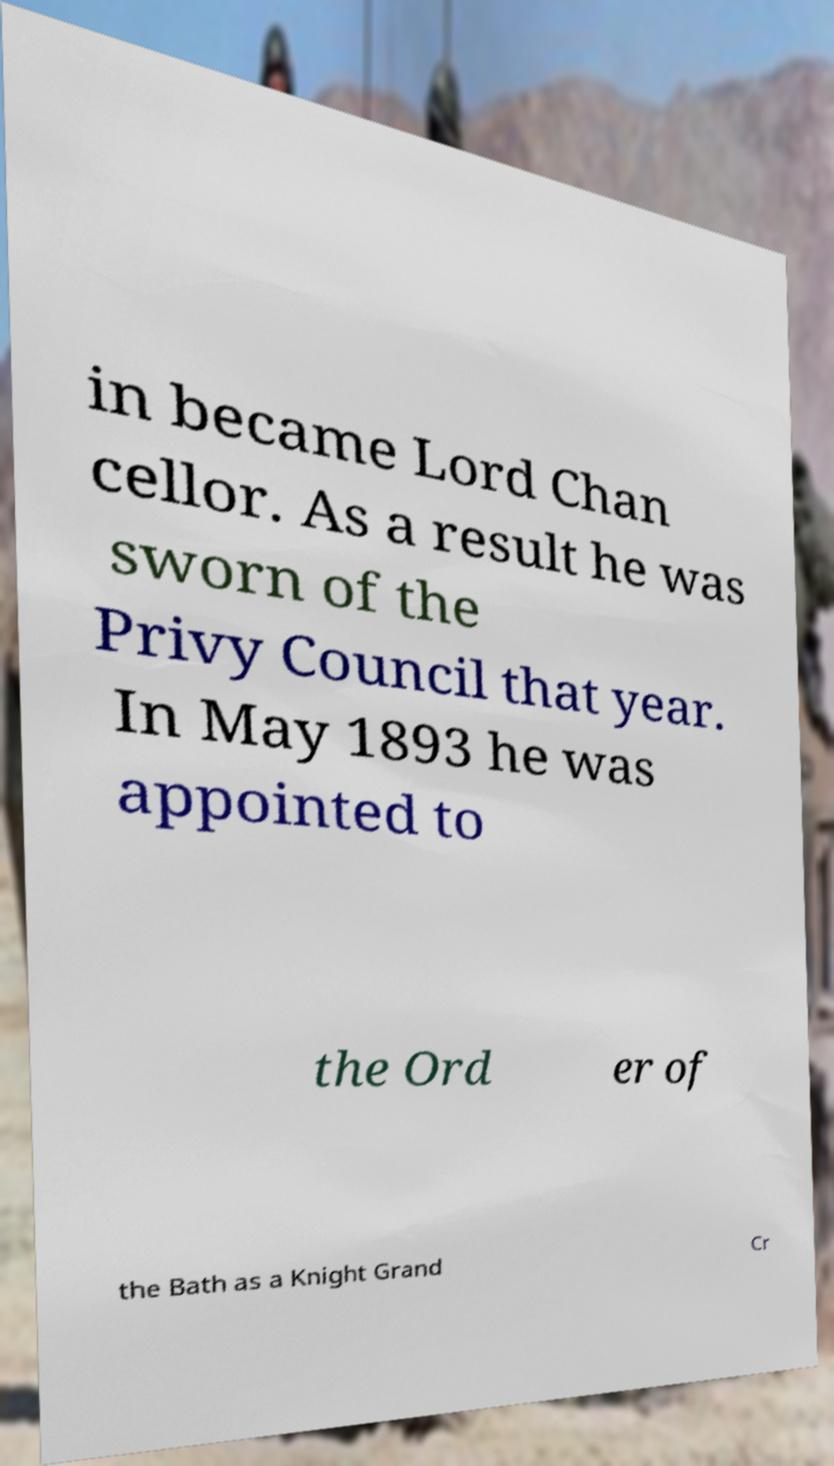Please identify and transcribe the text found in this image. in became Lord Chan cellor. As a result he was sworn of the Privy Council that year. In May 1893 he was appointed to the Ord er of the Bath as a Knight Grand Cr 